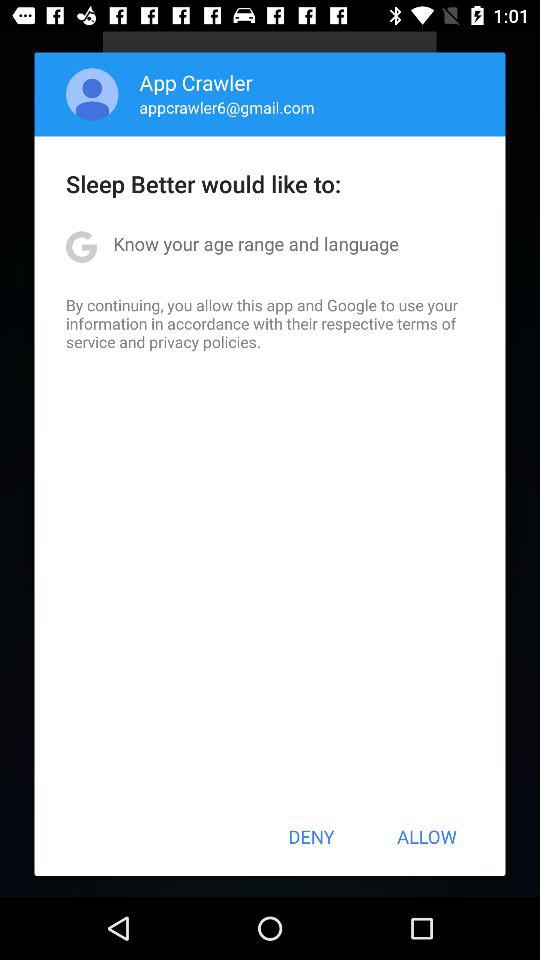What is the age range of the user?
When the provided information is insufficient, respond with <no answer>. <no answer> 